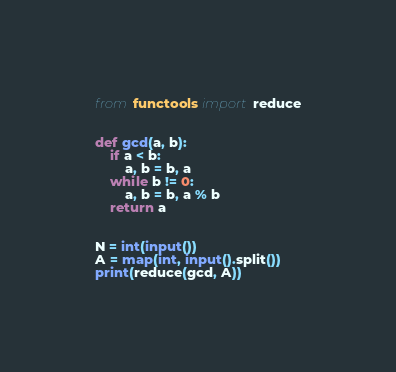Convert code to text. <code><loc_0><loc_0><loc_500><loc_500><_Python_>from functools import reduce


def gcd(a, b):
    if a < b:
        a, b = b, a
    while b != 0:
        a, b = b, a % b
    return a


N = int(input())
A = map(int, input().split())
print(reduce(gcd, A))
</code> 